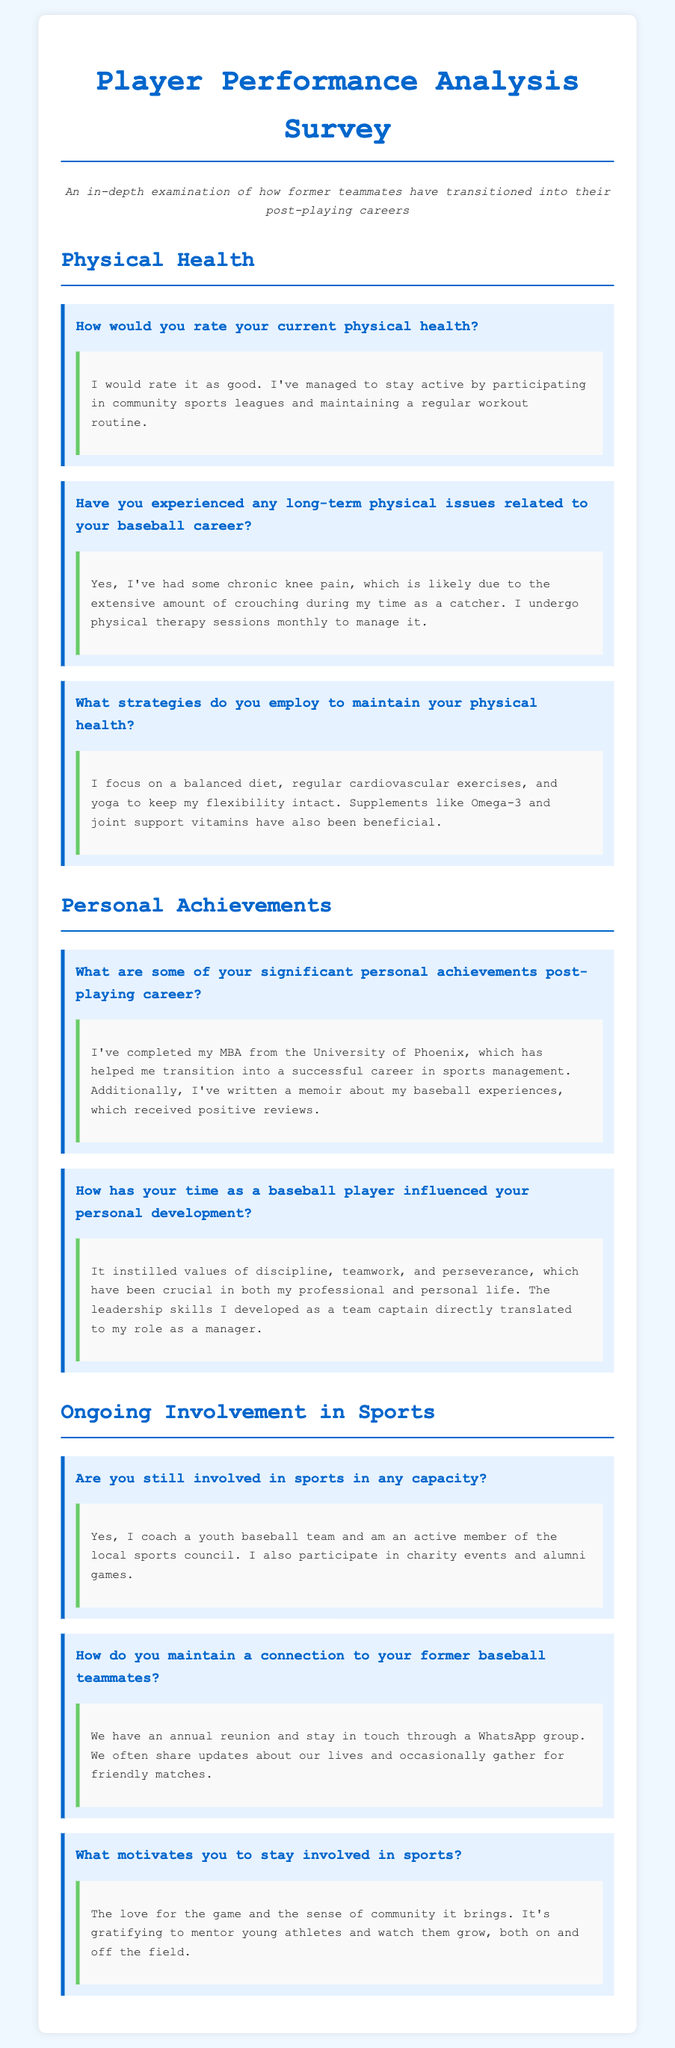How would you rate your current physical health? The document states that the individual rates their current physical health as good, indicating a positive self-assessment.
Answer: good What type of physical issues has the individual experienced? The respondent mentions chronic knee pain due to a specific role during their baseball career, highlighting a long-term consequence of their sports activities.
Answer: chronic knee pain What educational achievement did the individual attain? The survey response highlights the completion of an MBA, representing a key personal achievement post-playing career.
Answer: MBA In what capacity does the individual still engage with sports? The document reveals active involvement in coaching a youth baseball team and serving on a local sports council, indicating continued participation in sports.
Answer: coach and sports council member What motivates the individual to stay involved in sports? The response indicates that the love for the game and community are primary motivators, showcasing a passion for sports beyond personal participation.
Answer: love for the game and community 